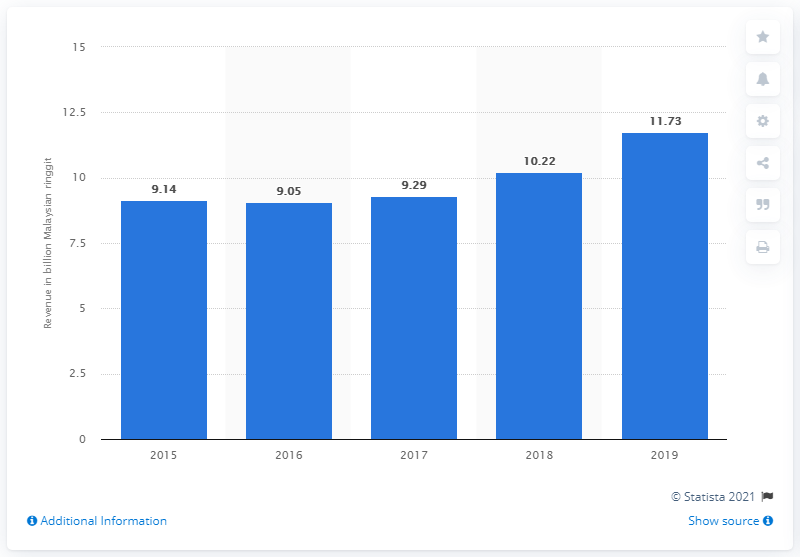List a handful of essential elements in this visual. Perdua's revenue in Malaysian ringgit for the fiscal year ending December 31, 2019 was 11.73. Perdua's revenue in 2018 was 10.22. 